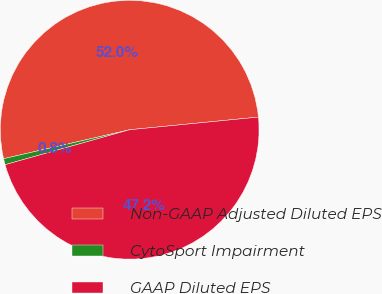<chart> <loc_0><loc_0><loc_500><loc_500><pie_chart><fcel>Non-GAAP Adjusted Diluted EPS<fcel>CytoSport Impairment<fcel>GAAP Diluted EPS<nl><fcel>52.03%<fcel>0.76%<fcel>47.21%<nl></chart> 